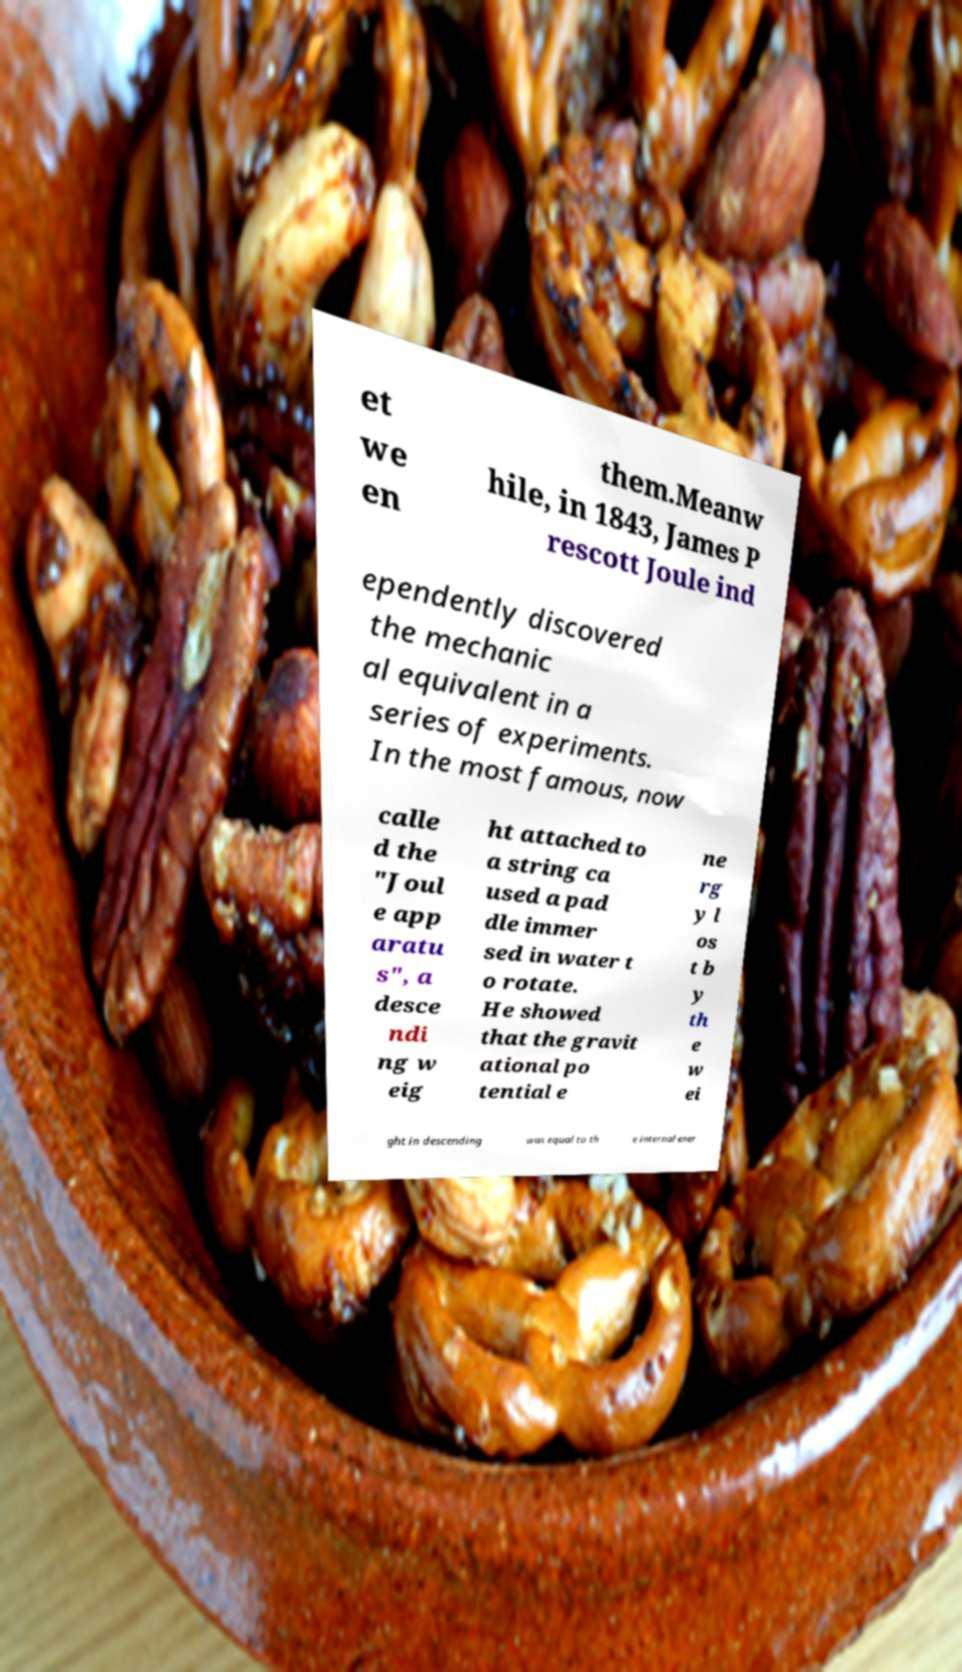What messages or text are displayed in this image? I need them in a readable, typed format. et we en them.Meanw hile, in 1843, James P rescott Joule ind ependently discovered the mechanic al equivalent in a series of experiments. In the most famous, now calle d the "Joul e app aratu s", a desce ndi ng w eig ht attached to a string ca used a pad dle immer sed in water t o rotate. He showed that the gravit ational po tential e ne rg y l os t b y th e w ei ght in descending was equal to th e internal ener 